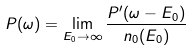Convert formula to latex. <formula><loc_0><loc_0><loc_500><loc_500>P ( \omega ) = \lim _ { E _ { 0 } \rightarrow \infty } \frac { P ^ { \prime } ( \omega - E _ { 0 } ) } { n _ { 0 } ( E _ { 0 } ) }</formula> 